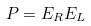<formula> <loc_0><loc_0><loc_500><loc_500>P = E _ { R } E _ { L }</formula> 